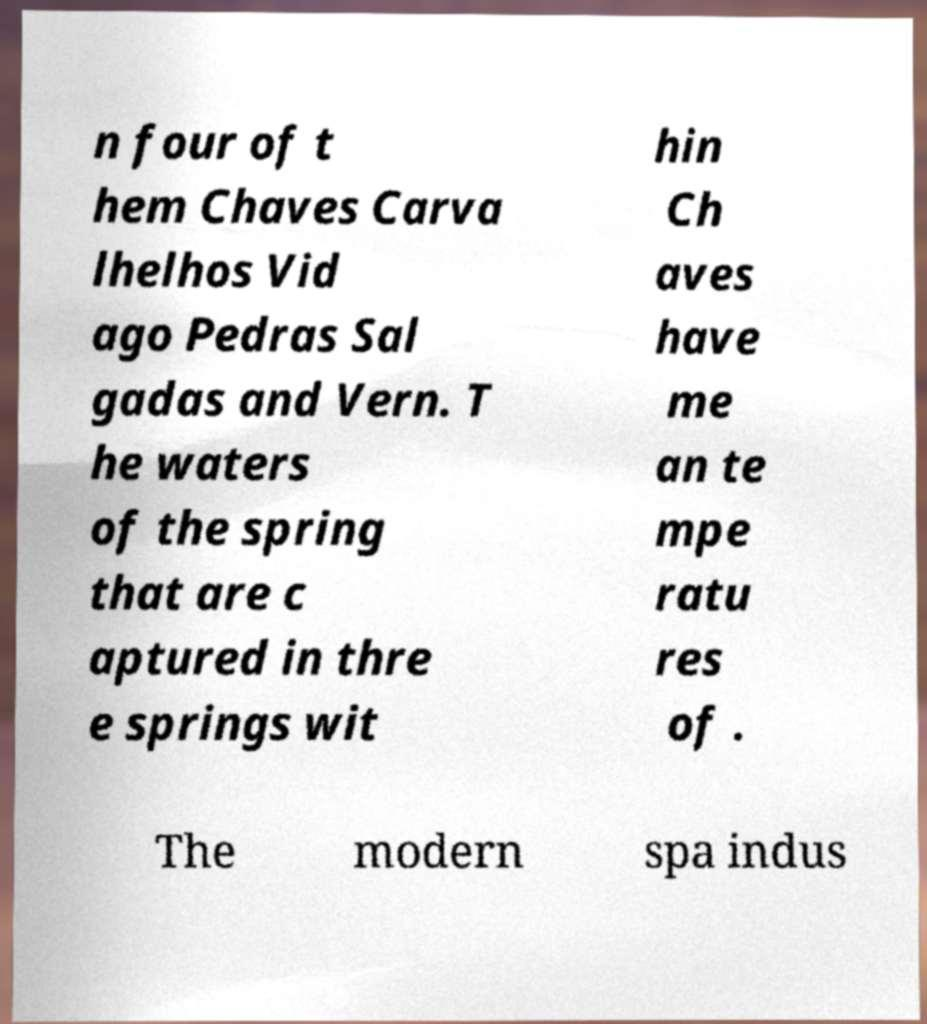Please identify and transcribe the text found in this image. n four of t hem Chaves Carva lhelhos Vid ago Pedras Sal gadas and Vern. T he waters of the spring that are c aptured in thre e springs wit hin Ch aves have me an te mpe ratu res of . The modern spa indus 